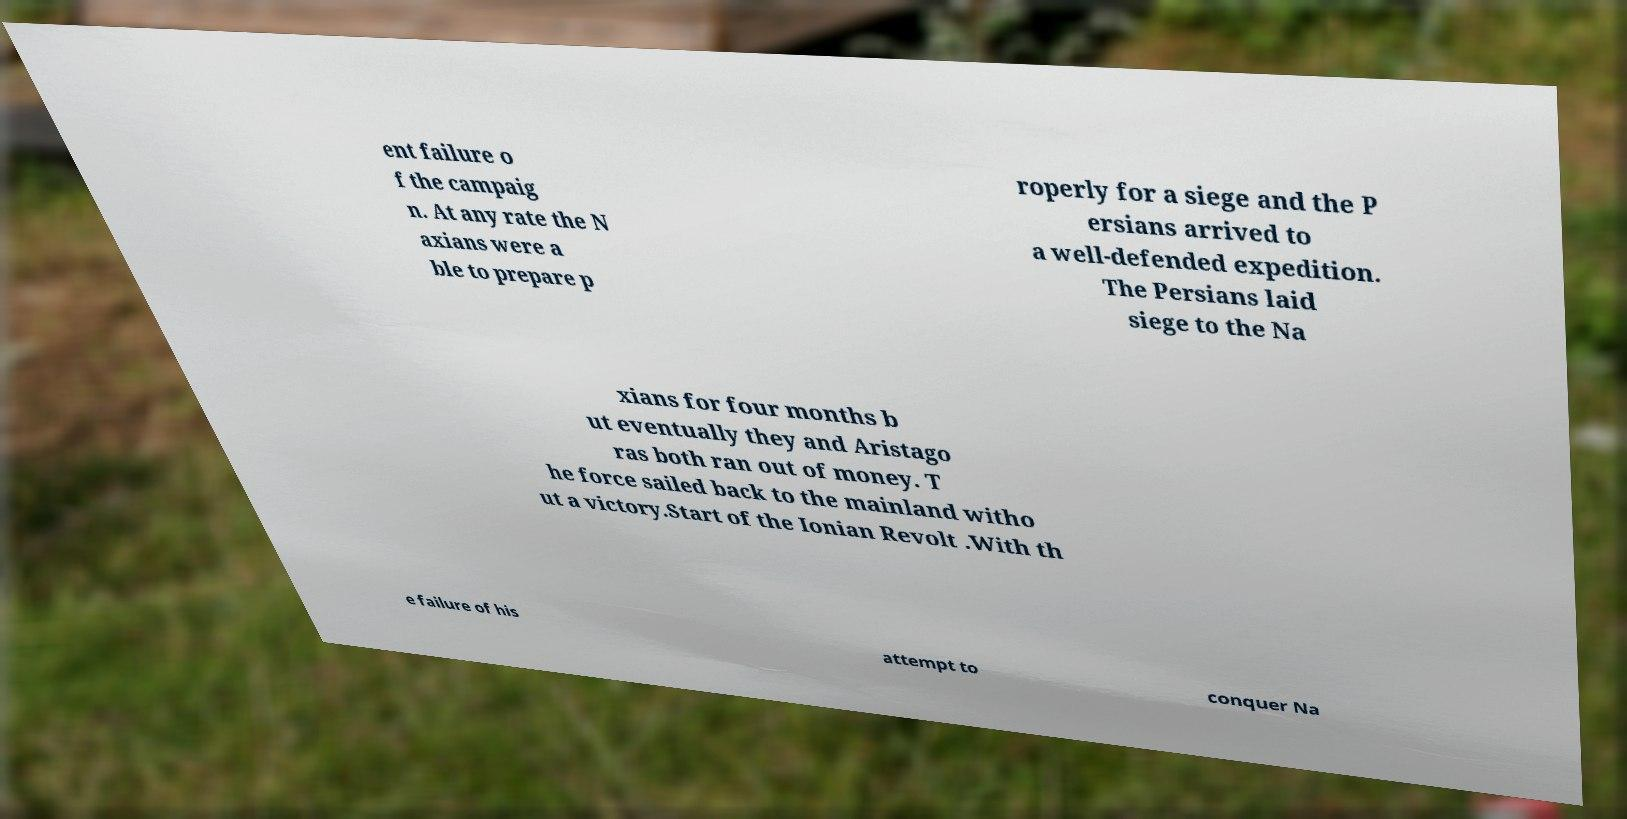Can you read and provide the text displayed in the image?This photo seems to have some interesting text. Can you extract and type it out for me? ent failure o f the campaig n. At any rate the N axians were a ble to prepare p roperly for a siege and the P ersians arrived to a well-defended expedition. The Persians laid siege to the Na xians for four months b ut eventually they and Aristago ras both ran out of money. T he force sailed back to the mainland witho ut a victory.Start of the Ionian Revolt .With th e failure of his attempt to conquer Na 